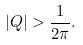Convert formula to latex. <formula><loc_0><loc_0><loc_500><loc_500>| Q | > \frac { 1 } { 2 \pi } .</formula> 